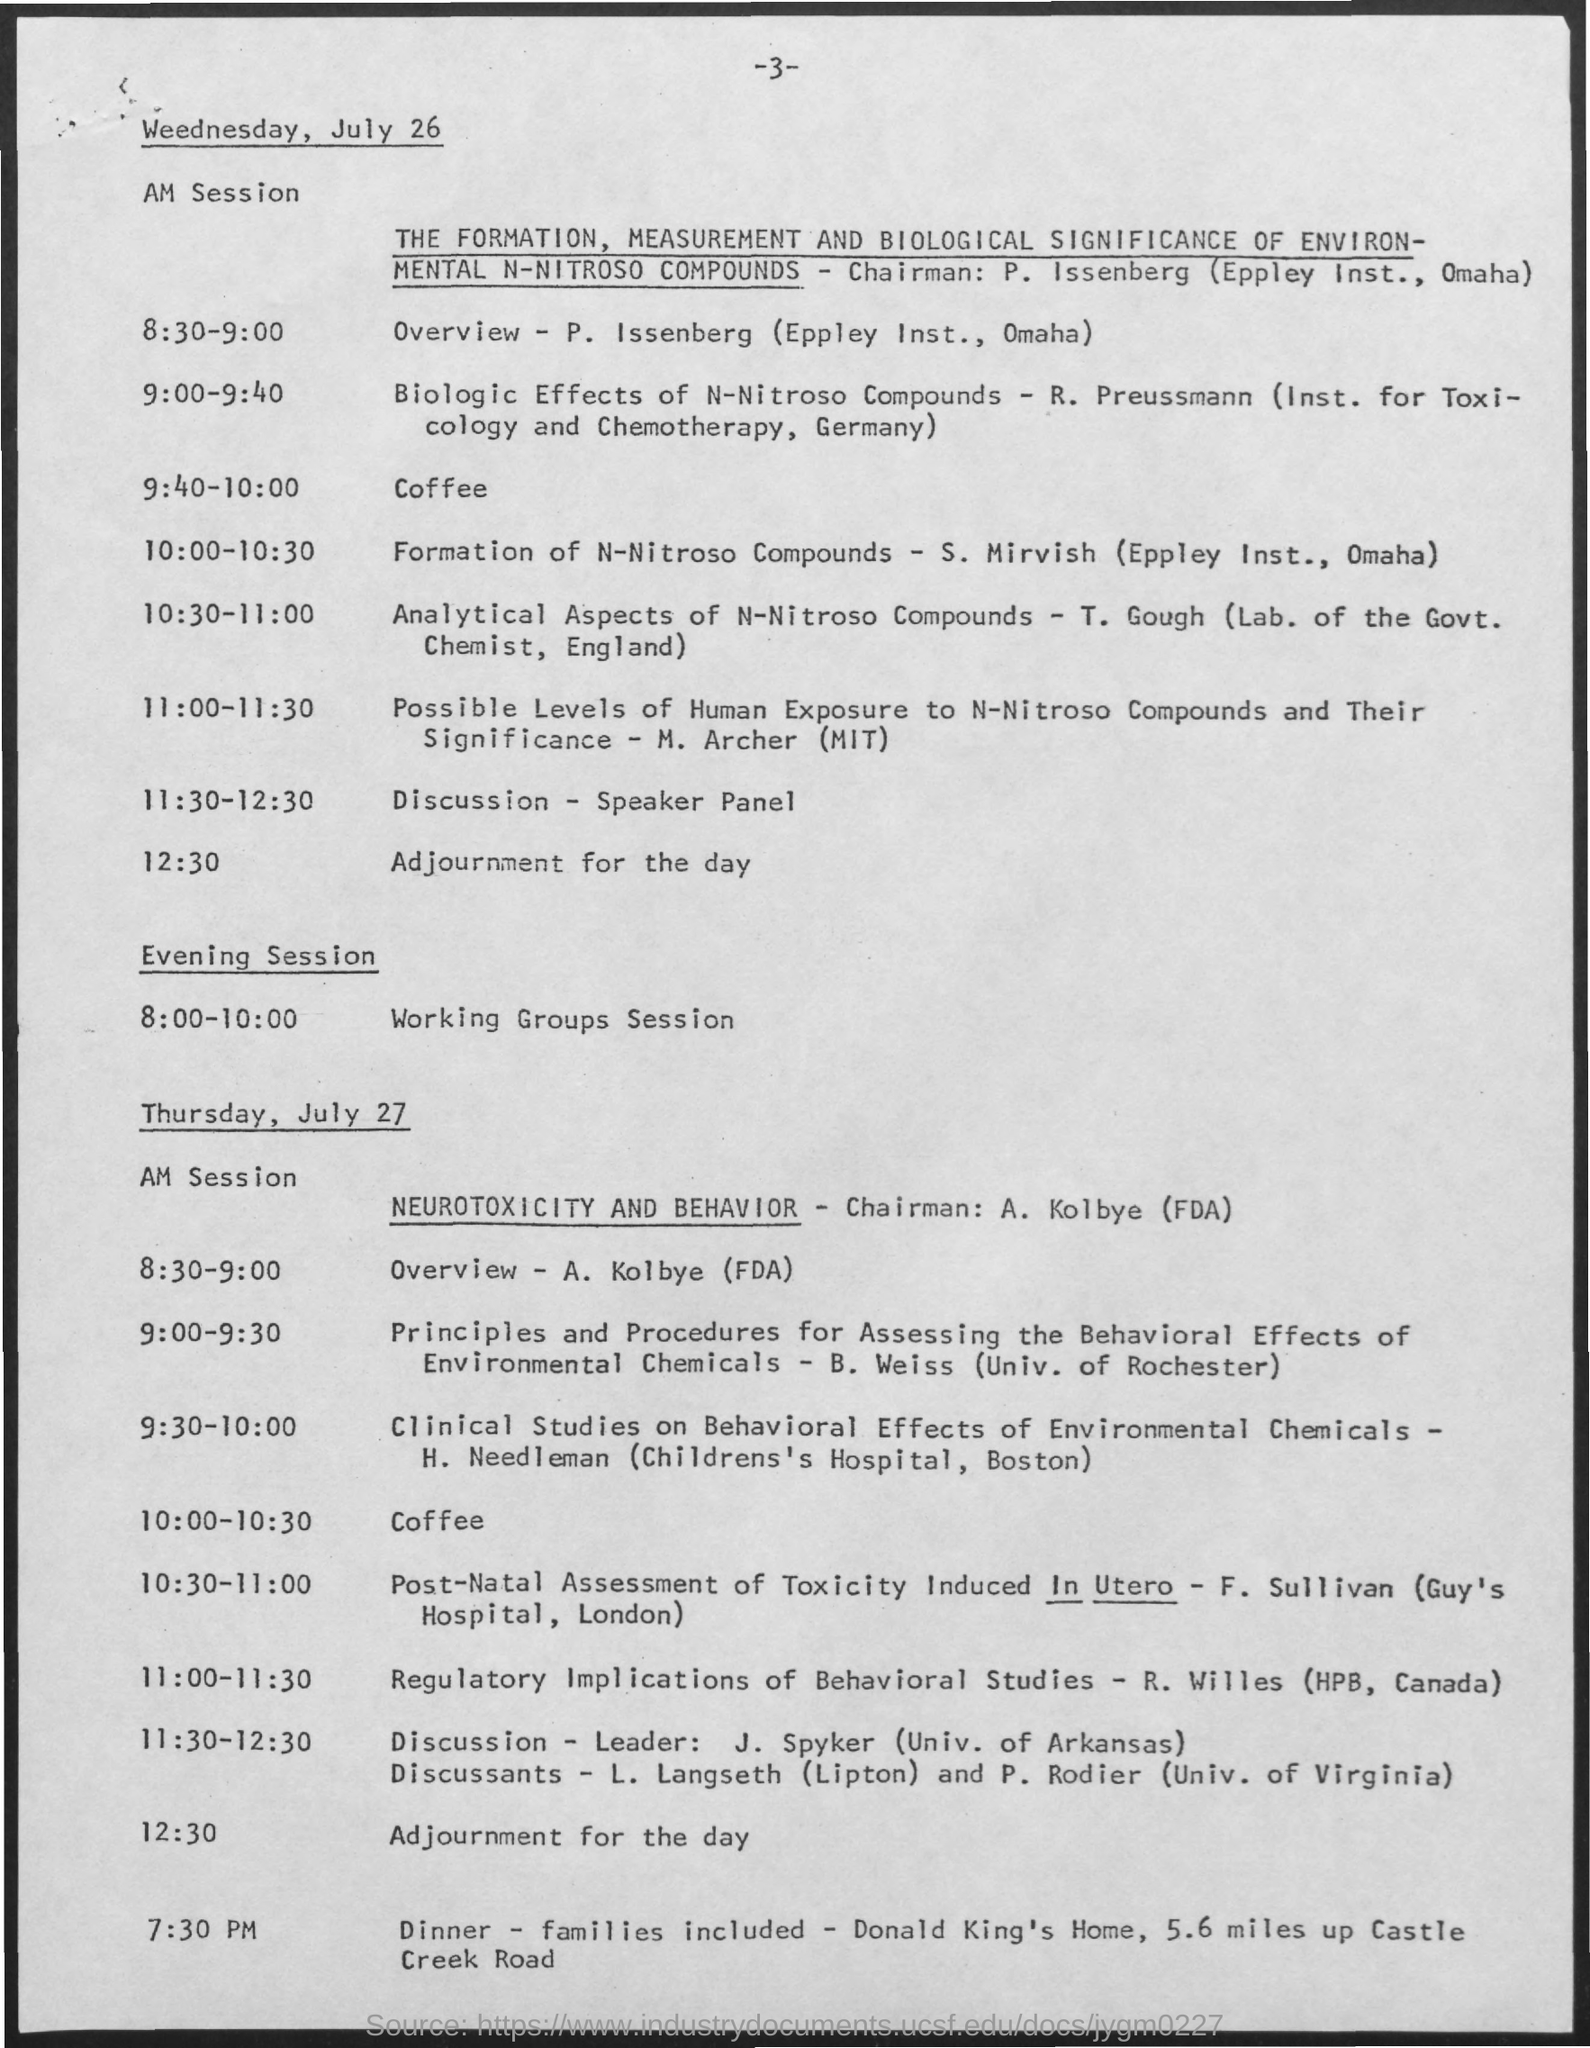What time is the Discussion-Speaker Panel on Wednesday, July 26?
Offer a very short reply. 11:30-12:30. What time is the Coffee on Wednesday, July 26?
Offer a very short reply. 9:40-10:00. When is the Adjourment for the day on Wednesday, July 26?
Offer a very short reply. 12:30. 